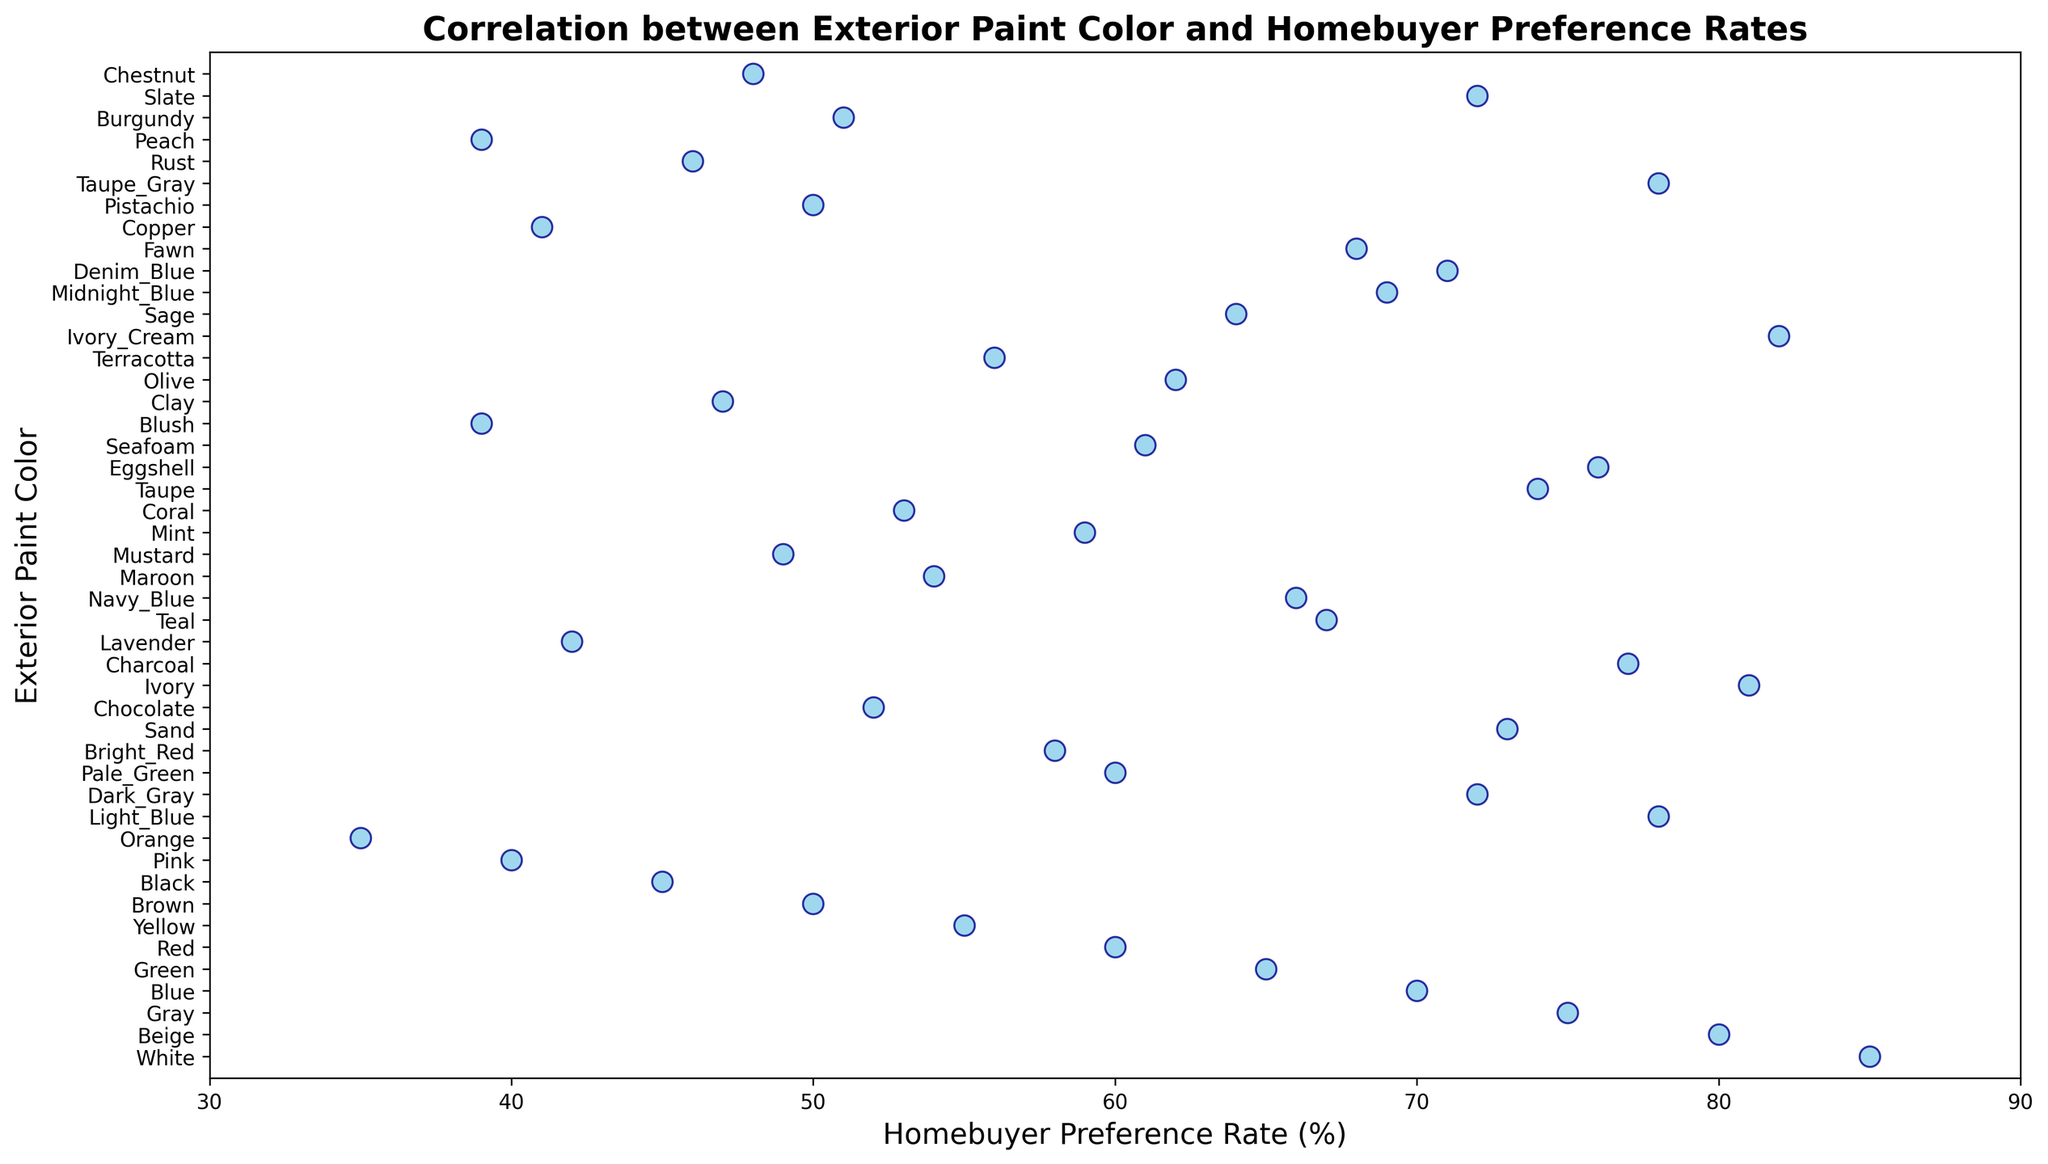What are the three exterior paint colors with the highest homebuyer preference rates? To find the top three exterior paint colors with the highest rates, look for the three highest points along the x-axis. They are White (85), Ivory_Cream (82), and Ivory (81).
Answer: White, Ivory_Cream, Ivory Which exterior paint color has the lowest homebuyer preference rate, and what is that rate? To identify the lowest preference rate, locate the leftmost point along the x-axis. The color corresponding to this point is Orange, with a rate of 35.
Answer: Orange, 35 How does the homebuyer preference rate for Beige compare to that for Charcoal? Identify the x-axis values for Beige and Charcoal. Beige is at 80, and Charcoal is at 77. Compare these values to see that Beige has a higher preference rate than Charcoal.
Answer: Beige has a higher preference rate than Charcoal What is the median homebuyer preference rate of the provided data set? To find the median, list all preference rates in ascending order and find the middle value. Since there are 38 data points, the median is the 19th value in the order. Arranged in order, the median preference rate is 61 (Seafoam's rate).
Answer: 61 Which exterior paint color has a preference rate closest to the average preference rate? First, calculate the average preference rate by summing all rates and dividing by the number of colors (38). The sum is 2473; thus, the average is 65.08. The color with a preference rate closest to 65.08 is Navy_Blue at 66.
Answer: Navy_Blue Are there any exterior paint colors with the same homebuyer preference rate, and if so, which ones? Look for overlapping points along the x-axis. The same rate can be seen at 60, shared by Red and Pale_Green.
Answer: Red and Pale_Green What is the range of the homebuyer preference rates? The range is calculated by subtracting the lowest rate from the highest rate. The highest rate is 85 (White) and the lowest is 35 (Orange). The range is 85 - 35 = 50.
Answer: 50 Which exterior paint colors are preferred over Teal? Teal has a rate of 67. Look for all colors to the right of Teal's rate on the x-axis. These include White, Ivory_Cream, Ivory, Beige, Taupe_Gray, Light_Blue, Eggshell, Charcoal, Slate, Denim_Blue, Sand, Taupe.
Answer: White, Ivory_Cream, Ivory, Beige, Taupe_Gray, Light_Blue, Eggshell, Charcoal, Slate, Denim_Blue, Sand, Taupe Is there a color group (like shades of blue) that generally seems to have higher preference rates? Identify color trends by categorizing shades: Blue shades include Blue, Light_Blue, Midnight_Blue, Navy_Blue, Denim_Blue, and Teal. Their rates are 70, 78, 69, 66, 71, and 67 respectively, mostly above the average rate of 65.08.
Answer: Yes, Blue shades generally have higher preference rates How does the preference rate trend as the paint color gets darker? Observe the darker shades like Black, Charcoal, and Dark_Gray, their rates are 45, 77, and 72 respectively. Moderately dark colors show high preference rates, but extremely dark colors like Black have lower rates, suggesting a trend where moderate darks are preferred over extremes.
Answer: Moderately dark colors are preferred over extremely dark colors 